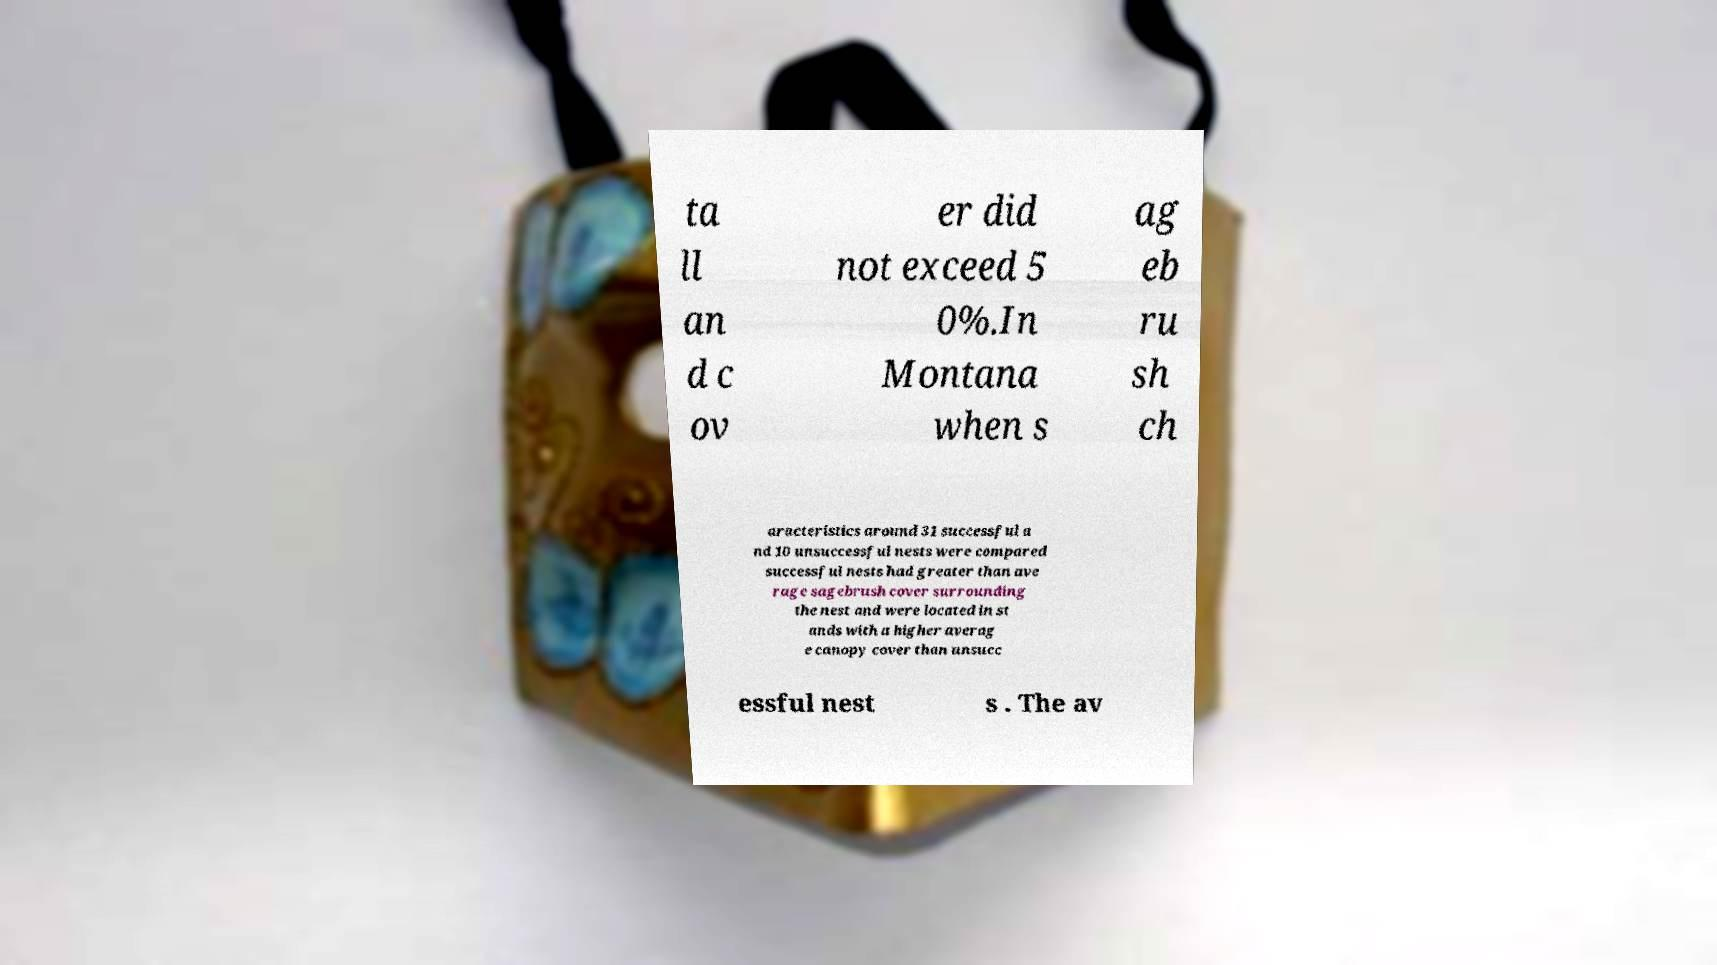Can you read and provide the text displayed in the image?This photo seems to have some interesting text. Can you extract and type it out for me? ta ll an d c ov er did not exceed 5 0%.In Montana when s ag eb ru sh ch aracteristics around 31 successful a nd 10 unsuccessful nests were compared successful nests had greater than ave rage sagebrush cover surrounding the nest and were located in st ands with a higher averag e canopy cover than unsucc essful nest s . The av 